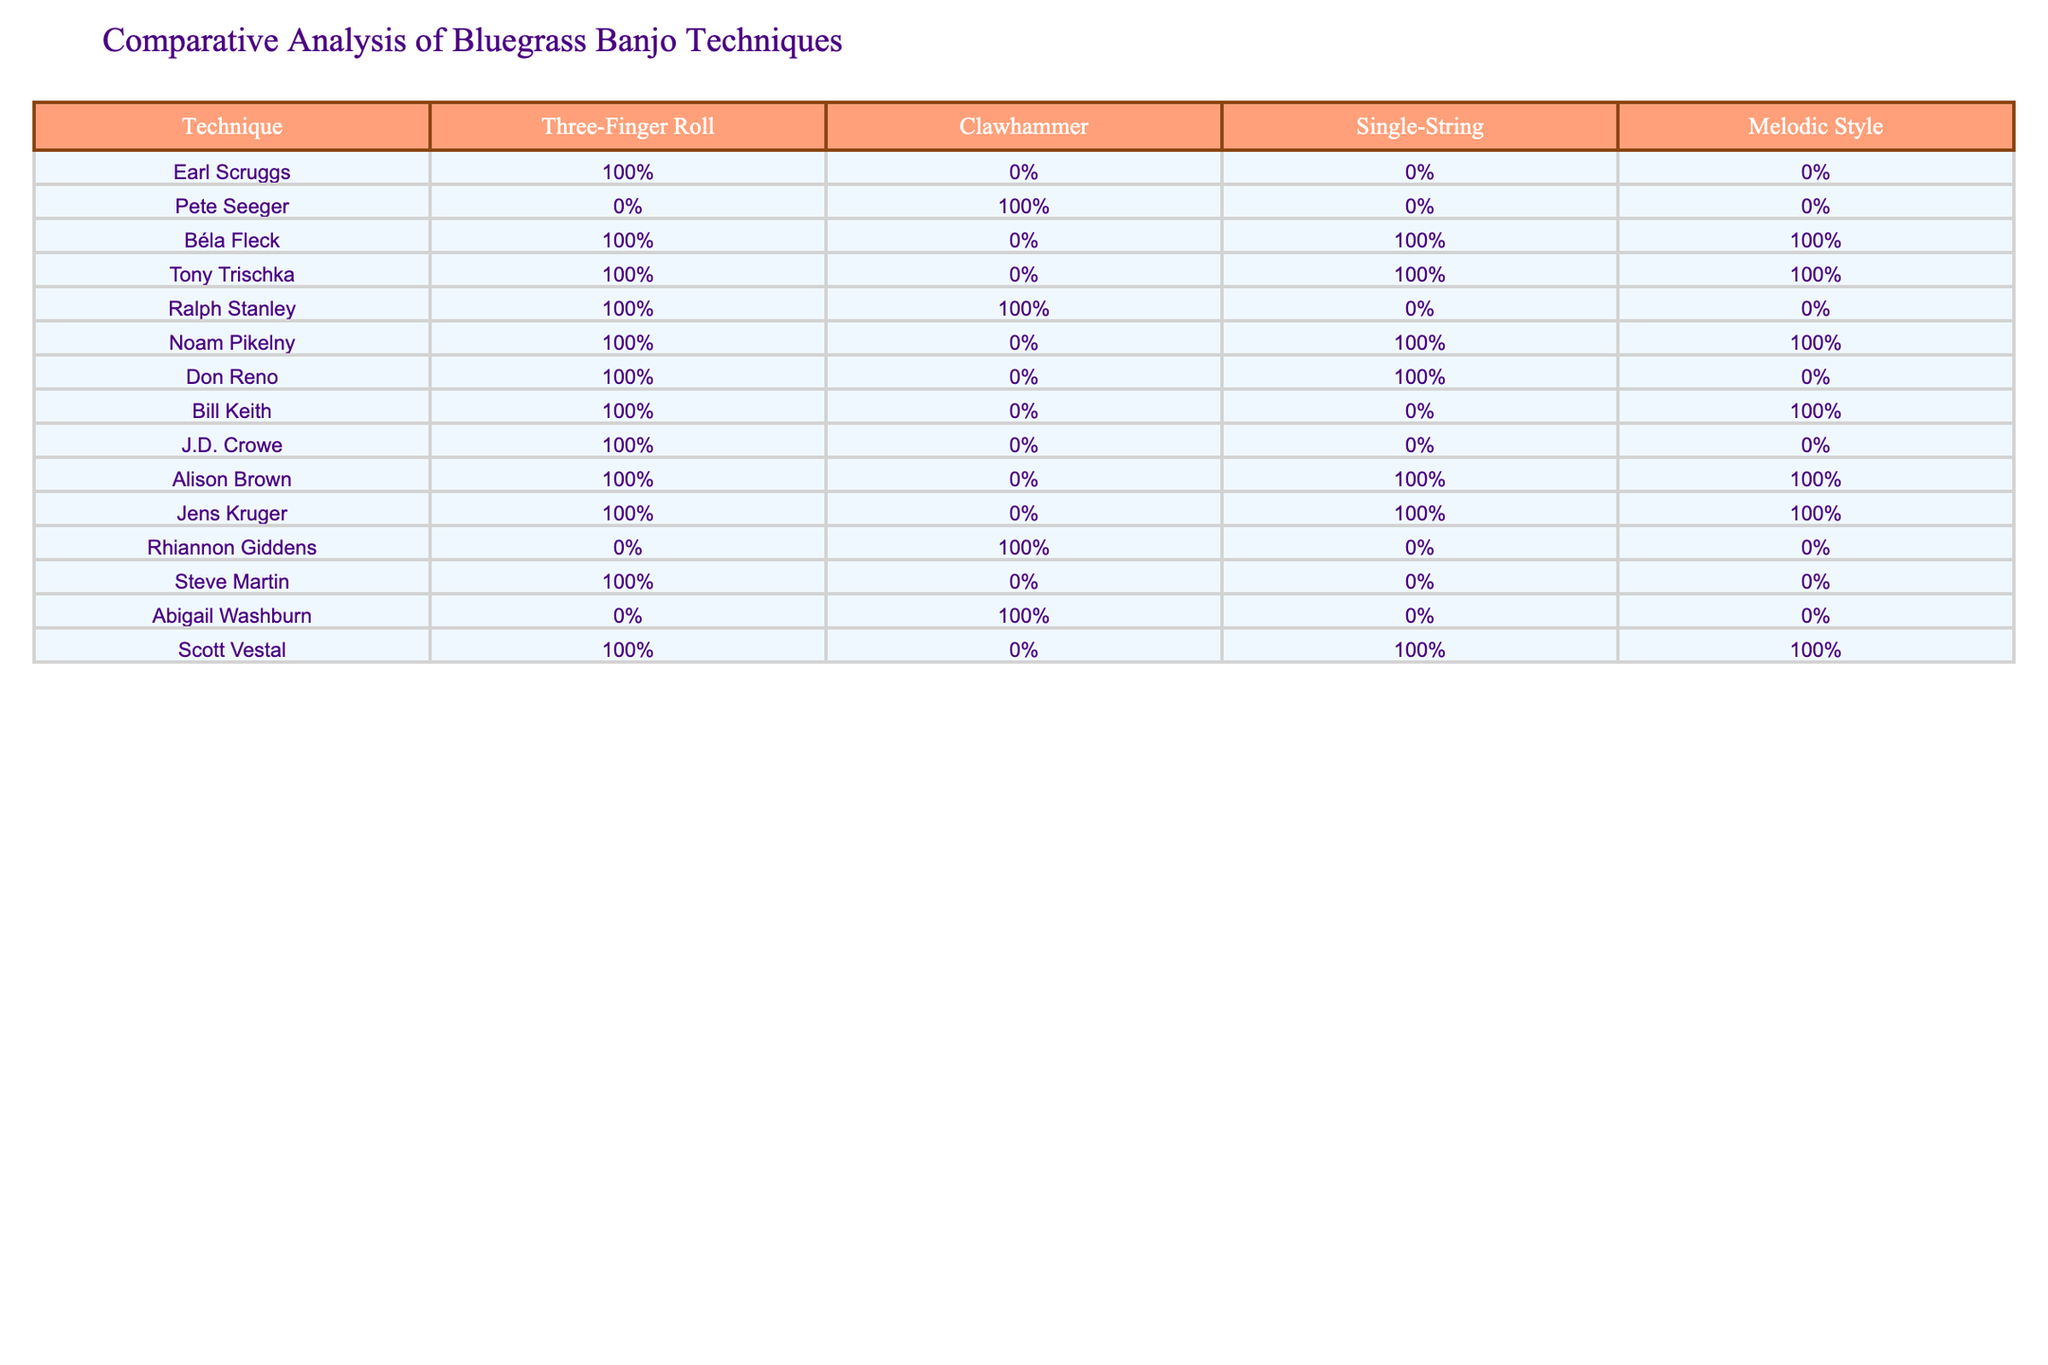What techniques did Earl Scruggs use? According to the table, Earl Scruggs practiced the Three-Finger Roll technique and did not use Clawhammer, Single-String, or Melodic Style techniques.
Answer: Three-Finger Roll Which banjo techniques are used by Pete Seeger? The table indicates that Pete Seeger exclusively used the Clawhammer technique and did not use the other three techniques.
Answer: Clawhammer How many techniques does Béla Fleck employ? From the table, Béla Fleck uses all four techniques: Three-Finger Roll, Single-String, and Melodic Style. This indicates a total of three different techniques.
Answer: Three Is it true that Rhiannon Giddens uses Clawhammer technique? Looking at the table, Rhiannon Giddens is confirmed to use the Clawhammer technique, as indicated by the true value in her row for that technique.
Answer: Yes Which musicians primarily used the Three-Finger Roll technique? Referring to the table, the musicians who mainly utilized the Three-Finger Roll are Earl Scruggs, Béla Fleck, Tony Trischka, Ralph Stanley, Noam Pikelny, Don Reno, Bill Keith, J.D. Crowe, Alison Brown, Jens Kruger, Scott Vestal, and Steve Martin, totaling eleven musicians.
Answer: Eleven How does the use of Melodic Style vary among musicians? By analyzing the table, we see that out of thirteen musicians, four (Béla Fleck, Tony Trischka, Bill Keith, and Alison Brown) used the Melodic Style technique. This means approximately 31% of the musicians employ that technique.
Answer: 31% Which musician employs the highest number of techniques? Evaluating the table, it shows that Béla Fleck, Tony Trischka, and Alison Brown each utilize four techniques, which is the highest among the musicians listed.
Answer: Béla Fleck, Tony Trischka, and Alison Brown Does any musician use Clawhammer and Melodic Style techniques together? According to the table, Ralph Stanley is the only musician who uses both Clawhammer and the Melodic Style techniques.
Answer: Yes What is the difference in technique usage between Ralph Stanley and Don Reno? The table indicates that Ralph Stanley uses three techniques (Three-Finger Roll, Clawhammer, and not Single-String or Melodic Style), whereas Don Reno uses only two techniques (Three-Finger Roll and Single-String). This results in Ralph having one more technique than Don.
Answer: One 